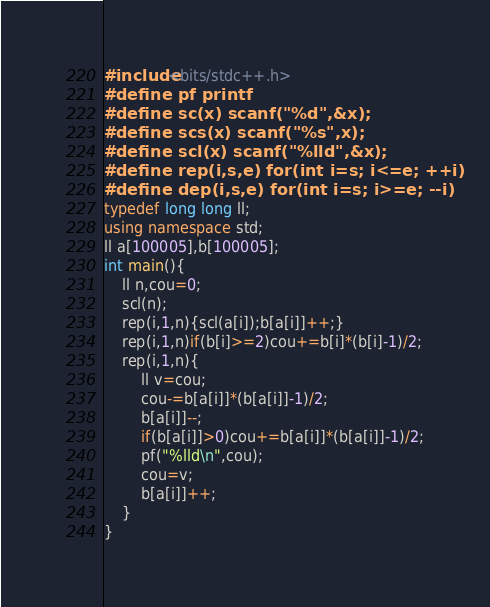<code> <loc_0><loc_0><loc_500><loc_500><_C++_>#include<bits/stdc++.h>
#define pf printf
#define sc(x) scanf("%d",&x);
#define scs(x) scanf("%s",x);
#define scl(x) scanf("%lld",&x);
#define rep(i,s,e) for(int i=s; i<=e; ++i)
#define dep(i,s,e) for(int i=s; i>=e; --i)
typedef long long ll;
using namespace std;
ll a[100005],b[100005];
int main(){
	ll n,cou=0;
	scl(n);
	rep(i,1,n){scl(a[i]);b[a[i]]++;}
	rep(i,1,n)if(b[i]>=2)cou+=b[i]*(b[i]-1)/2;
	rep(i,1,n){
		ll v=cou;
		cou-=b[a[i]]*(b[a[i]]-1)/2;
		b[a[i]]--;
		if(b[a[i]]>0)cou+=b[a[i]]*(b[a[i]]-1)/2;
		pf("%lld\n",cou);
		cou=v;
		b[a[i]]++;
	}
}</code> 